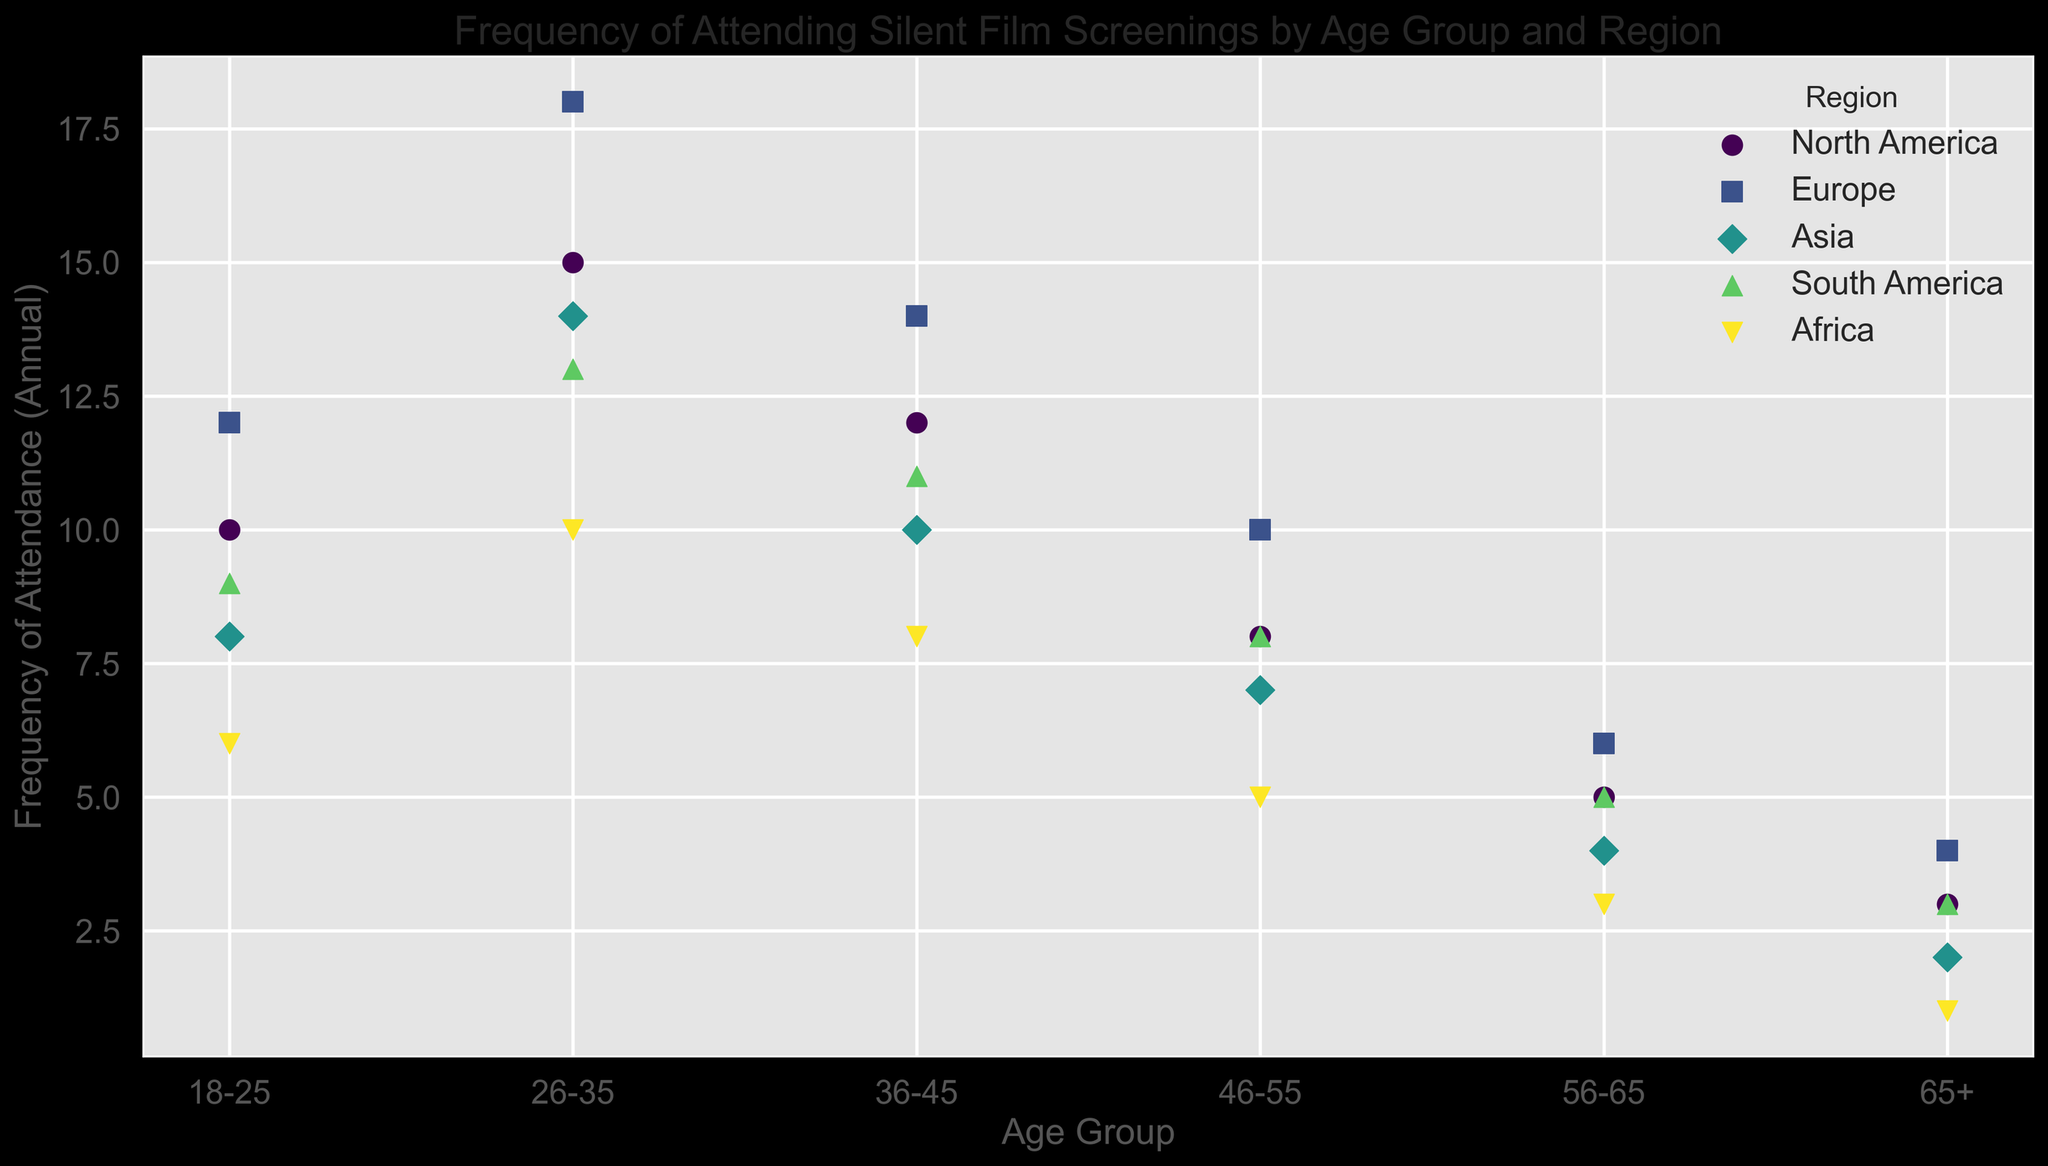What's the predominant age group for silent film screenings in Europe? Looking at the plot, the age group with the highest frequency of attendance in Europe has to be identified. According to the legend, Europe is represented by a specific color and marker. The point with the highest y-axis value within the Europe series will indicate the predominant age group. The '26-35' age group has the highest attendance in Europe.
Answer: 26-35 Which region has the highest attendance rates among the 18-25 age group? First, identify all the points associated with the '18-25' age group. Then, compare the y-axis values corresponding to different regions for this age group. The region with the highest y-axis value represents the highest attendance rate. Europe's attendance rate at the age of 18-25 is 12, which is the highest compared to other regions.
Answer: Europe In which region and age group is the attendance rate exactly 5? Look for the specific y-axis value of 5 across all regions and age groups. Identify the marker and color corresponding to this value, then trace it back to the region and age group. The 56-65 age group in North America and South America has an attendance rate of 5.
Answer: North America and South America, 56-65 Between Africa and Asia, which region has a higher attendance rate for the 36-45 age group? Find the points corresponding to the 36-45 age group for Africa and Asia from the legend. Compare their y-axis values, where higher value indicates higher attendance. The attendance rate for Asia is 10, and for Africa, it is 8. Thus, Asia has a higher attendance rate in this age group.
Answer: Asia What is the average attendance rate for the 26-35 age group across all regions? Add the attendance rates for the 26-35 age group in each region: North America (15), Europe (18), Asia (14), South America (13), and Africa (10). Sum these values and divide by the number of regions. Calculation: (15 + 18 + 14 + 13 + 10) / 5 = 70/5 = 14. The average attendance rate for this age group is 14.
Answer: 14 Which region has the lowest overall attendance rate for the 65+ age group? Identify the y-axis values corresponding to the 65+ age group for all regions. The region with the smallest y-axis value has the lowest attendance rate. The y-axis values are North America (3), Europe (4), Asia (2), South America (3), and Africa (1). Hence, Africa has the lowest attendance.
Answer: Africa How does the attendance for the 46-55 age group in South America compare to Africa? Find the points corresponding to the 46-55 age group in South America and Africa. Compare their y-axis values. South America shows a value of 8, while Africa shows a value of 5 Therefore, South America's attendance rate is higher.
Answer: South America Between the 18-25 and 65+ age groups, which has broader regional attendance rates? Look at the y-axis spread (range) of frequencies for these age groups across all regions. For the 18-25 group, the range is from 6 to 12 (6 units). For the 65+ group, the range is from 1 to 4 (3 units). Therefore, the 18-25 age group has a broader range of attendance rates.
Answer: 18-25 Which two age groups have the closest attendance rates in Asia? Identify the y-axis values for all age groups in the Asia region. Compare the values pairwise to determine which two are closest. The values are 8 (18-25), 14 (26-35), 10 (36-45), 7 (46-55), 4 (56-65), and 2 (65+). The closest pair is 7 (46-55) and 8 (18-25), with a difference of 1.
Answer: 18-25 and 46-55 